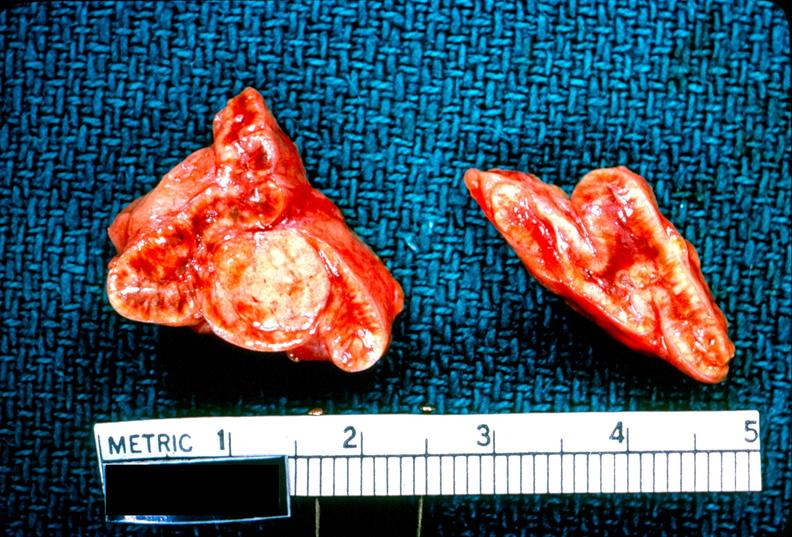does this image show adrenal, cortical adenoma aldosteronism?
Answer the question using a single word or phrase. Yes 